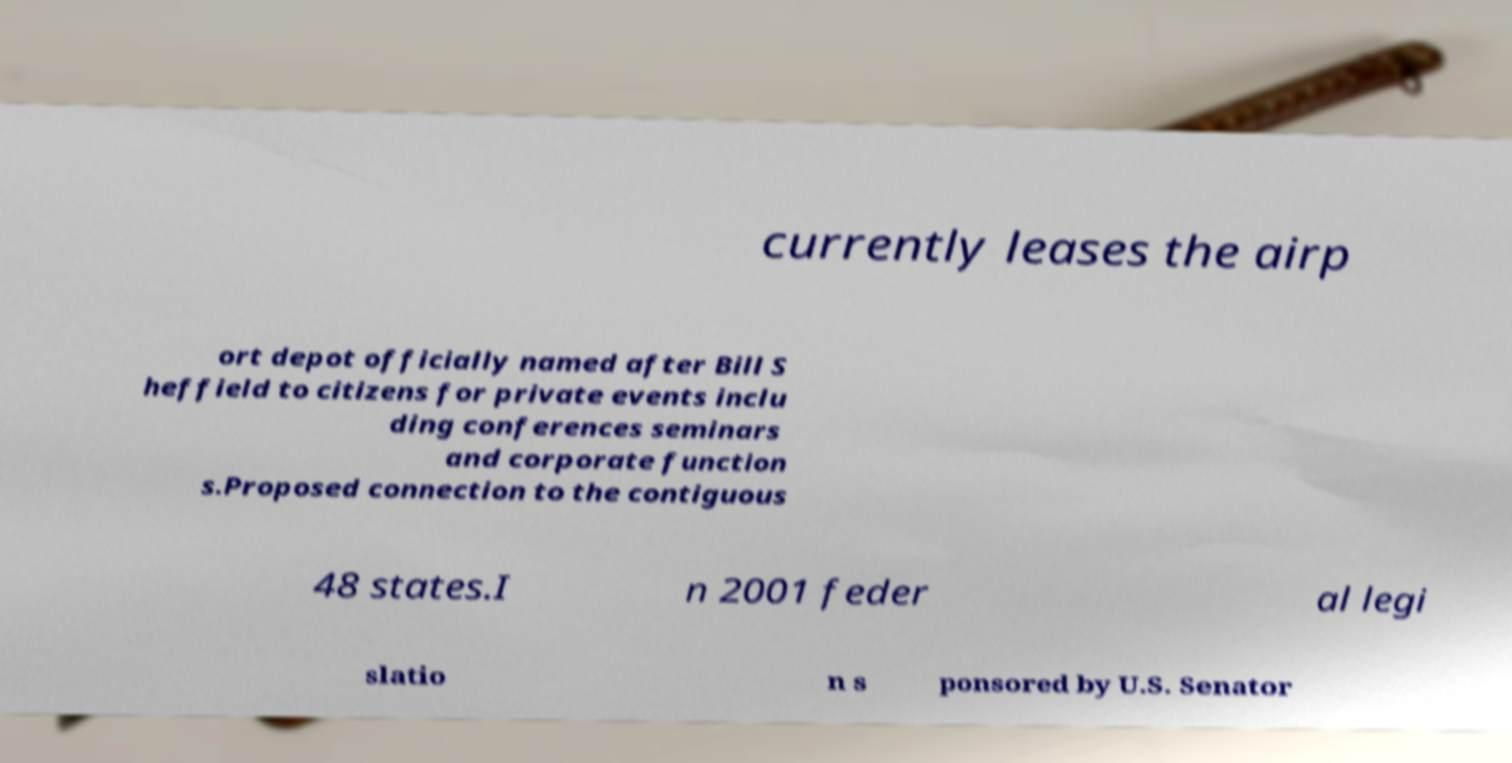Can you read and provide the text displayed in the image?This photo seems to have some interesting text. Can you extract and type it out for me? currently leases the airp ort depot officially named after Bill S heffield to citizens for private events inclu ding conferences seminars and corporate function s.Proposed connection to the contiguous 48 states.I n 2001 feder al legi slatio n s ponsored by U.S. Senator 